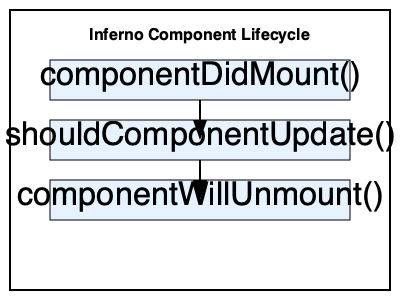In an Inferno application, which lifecycle method should be used to optimize performance by preventing unnecessary re-renders of a component? To optimize the performance of an Inferno application, we need to understand the component lifecycle methods and their purposes:

1. componentDidMount(): This method is called after the component is mounted to the DOM. It's useful for initial setup, but not for optimizing re-renders.

2. shouldComponentUpdate(nextProps, nextState): This method is called before rendering when new props or state are received. It returns a boolean value that determines whether the component should update.

3. componentWillUnmount(): This method is called just before the component is unmounted from the DOM. It's used for cleanup tasks, not for optimizing renders.

Among these methods, shouldComponentUpdate() is specifically designed for performance optimization. By implementing this method, we can control when a component should re-render based on changes in props or state.

To use shouldComponentUpdate() effectively:

1. Compare the current props and state with the next props and state.
2. Return true if the component should update, or false if it shouldn't.

For example:

```javascript
shouldComponentUpdate(nextProps, nextState) {
  return nextProps.importantProp !== this.props.importantProp || nextState.criticalState !== this.state.criticalState;
}
```

This implementation will only allow the component to re-render if importantProp or criticalState has changed, preventing unnecessary renders and improving performance.
Answer: shouldComponentUpdate() 